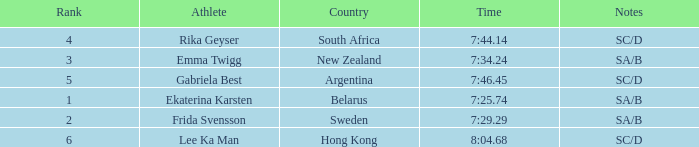What is the total rank for the athlete that had a race time of 7:34.24? 1.0. 